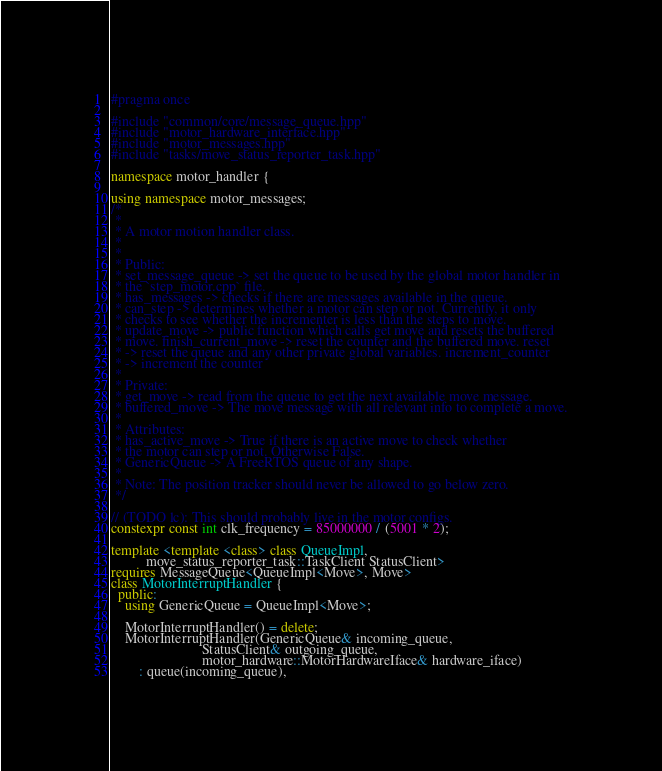<code> <loc_0><loc_0><loc_500><loc_500><_C++_>#pragma once

#include "common/core/message_queue.hpp"
#include "motor_hardware_interface.hpp"
#include "motor_messages.hpp"
#include "tasks/move_status_reporter_task.hpp"

namespace motor_handler {

using namespace motor_messages;
/*
 *
 * A motor motion handler class.
 *
 *
 * Public:
 * set_message_queue -> set the queue to be used by the global motor handler in
 * the `step_motor.cpp` file.
 * has_messages -> checks if there are messages available in the queue.
 * can_step -> determines whether a motor can step or not. Currently, it only
 * checks to see whether the incrementer is less than the steps to move.
 * update_move -> public function which calls get move and resets the buffered
 * move. finish_current_move -> reset the counter and the buffered move. reset
 * -> reset the queue and any other private global variables. increment_counter
 * -> increment the counter
 *
 * Private:
 * get_move -> read from the queue to get the next available move message.
 * buffered_move -> The move message with all relevant info to complete a move.
 *
 * Attributes:
 * has_active_move -> True if there is an active move to check whether
 * the motor can step or not. Otherwise False.
 * GenericQueue -> A FreeRTOS queue of any shape.
 *
 * Note: The position tracker should never be allowed to go below zero.
 */

// (TODO lc): This should probably live in the motor configs.
constexpr const int clk_frequency = 85000000 / (5001 * 2);

template <template <class> class QueueImpl,
          move_status_reporter_task::TaskClient StatusClient>
requires MessageQueue<QueueImpl<Move>, Move>
class MotorInterruptHandler {
  public:
    using GenericQueue = QueueImpl<Move>;

    MotorInterruptHandler() = delete;
    MotorInterruptHandler(GenericQueue& incoming_queue,
                          StatusClient& outgoing_queue,
                          motor_hardware::MotorHardwareIface& hardware_iface)
        : queue(incoming_queue),</code> 